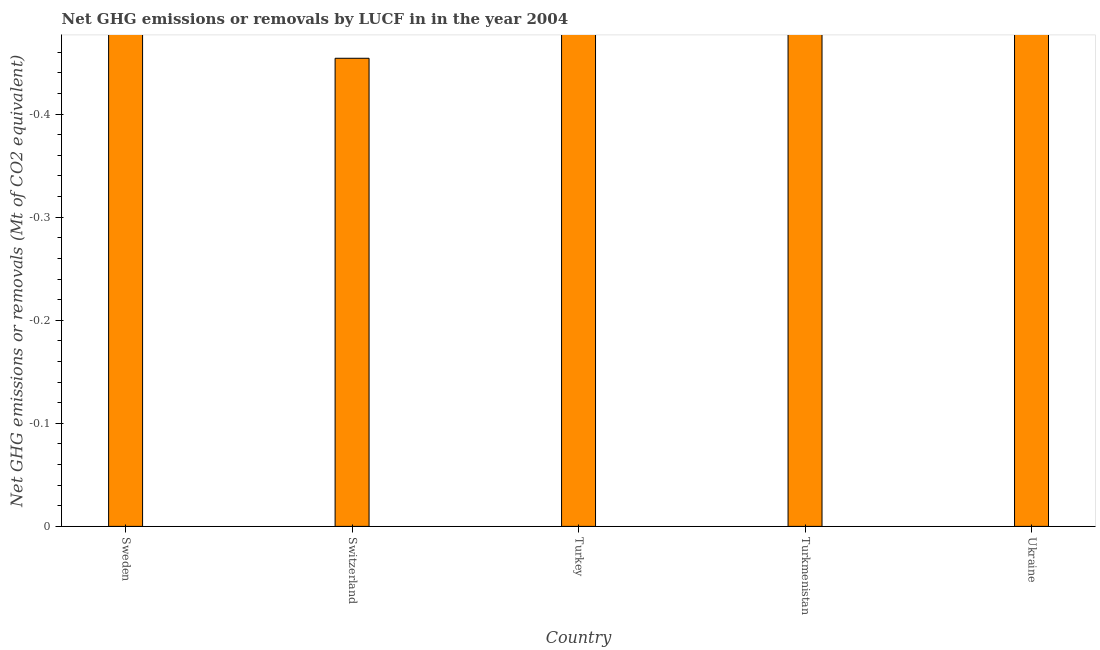Does the graph contain any zero values?
Your answer should be compact. Yes. What is the title of the graph?
Offer a very short reply. Net GHG emissions or removals by LUCF in in the year 2004. What is the label or title of the X-axis?
Ensure brevity in your answer.  Country. What is the label or title of the Y-axis?
Make the answer very short. Net GHG emissions or removals (Mt of CO2 equivalent). What is the ghg net emissions or removals in Switzerland?
Give a very brief answer. 0. What is the sum of the ghg net emissions or removals?
Give a very brief answer. 0. What is the average ghg net emissions or removals per country?
Ensure brevity in your answer.  0. In how many countries, is the ghg net emissions or removals greater than the average ghg net emissions or removals taken over all countries?
Offer a very short reply. 0. How many bars are there?
Your answer should be very brief. 0. What is the difference between two consecutive major ticks on the Y-axis?
Make the answer very short. 0.1. What is the Net GHG emissions or removals (Mt of CO2 equivalent) in Sweden?
Provide a short and direct response. 0. What is the Net GHG emissions or removals (Mt of CO2 equivalent) of Switzerland?
Provide a short and direct response. 0. What is the Net GHG emissions or removals (Mt of CO2 equivalent) in Turkmenistan?
Keep it short and to the point. 0. What is the Net GHG emissions or removals (Mt of CO2 equivalent) of Ukraine?
Offer a very short reply. 0. 